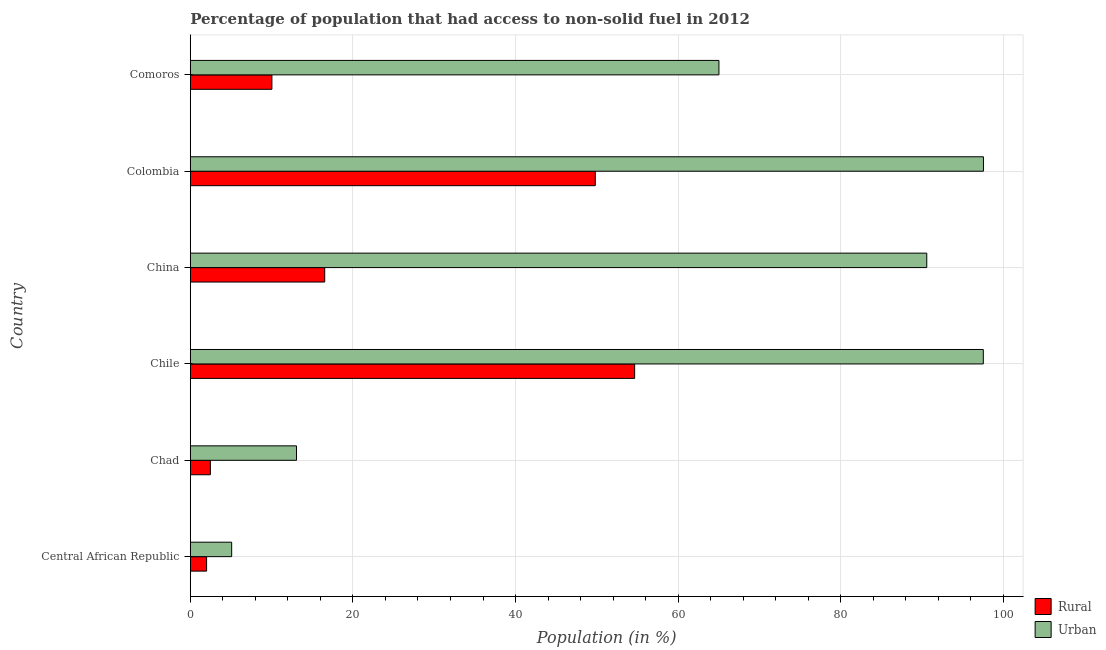Are the number of bars on each tick of the Y-axis equal?
Your answer should be very brief. Yes. What is the label of the 1st group of bars from the top?
Your answer should be compact. Comoros. In how many cases, is the number of bars for a given country not equal to the number of legend labels?
Your answer should be compact. 0. What is the rural population in Colombia?
Offer a terse response. 49.81. Across all countries, what is the maximum urban population?
Your answer should be compact. 97.55. Across all countries, what is the minimum rural population?
Your answer should be very brief. 2. In which country was the urban population minimum?
Your answer should be very brief. Central African Republic. What is the total rural population in the graph?
Keep it short and to the point. 135.5. What is the difference between the urban population in Chad and that in China?
Offer a very short reply. -77.51. What is the difference between the rural population in Central African Republic and the urban population in Chad?
Your response must be concise. -11.06. What is the average rural population per country?
Give a very brief answer. 22.58. What is the difference between the rural population and urban population in Comoros?
Your response must be concise. -54.98. What is the ratio of the urban population in Chad to that in Colombia?
Give a very brief answer. 0.13. Is the difference between the urban population in Chad and Chile greater than the difference between the rural population in Chad and Chile?
Provide a succinct answer. No. What is the difference between the highest and the second highest rural population?
Give a very brief answer. 4.84. What is the difference between the highest and the lowest urban population?
Give a very brief answer. 92.46. What does the 1st bar from the top in Chad represents?
Make the answer very short. Urban. What does the 2nd bar from the bottom in Central African Republic represents?
Ensure brevity in your answer.  Urban. How many bars are there?
Provide a short and direct response. 12. Where does the legend appear in the graph?
Offer a very short reply. Bottom right. How many legend labels are there?
Give a very brief answer. 2. How are the legend labels stacked?
Provide a short and direct response. Vertical. What is the title of the graph?
Provide a succinct answer. Percentage of population that had access to non-solid fuel in 2012. Does "Infant" appear as one of the legend labels in the graph?
Keep it short and to the point. No. What is the label or title of the X-axis?
Make the answer very short. Population (in %). What is the Population (in %) in Rural in Central African Republic?
Your answer should be very brief. 2. What is the Population (in %) of Urban in Central African Republic?
Your answer should be very brief. 5.09. What is the Population (in %) in Rural in Chad?
Give a very brief answer. 2.47. What is the Population (in %) in Urban in Chad?
Provide a short and direct response. 13.06. What is the Population (in %) in Rural in Chile?
Keep it short and to the point. 54.65. What is the Population (in %) in Urban in Chile?
Offer a very short reply. 97.53. What is the Population (in %) of Rural in China?
Keep it short and to the point. 16.53. What is the Population (in %) in Urban in China?
Make the answer very short. 90.57. What is the Population (in %) in Rural in Colombia?
Ensure brevity in your answer.  49.81. What is the Population (in %) in Urban in Colombia?
Your answer should be very brief. 97.55. What is the Population (in %) of Rural in Comoros?
Ensure brevity in your answer.  10.04. What is the Population (in %) of Urban in Comoros?
Provide a short and direct response. 65.02. Across all countries, what is the maximum Population (in %) of Rural?
Keep it short and to the point. 54.65. Across all countries, what is the maximum Population (in %) in Urban?
Keep it short and to the point. 97.55. Across all countries, what is the minimum Population (in %) in Rural?
Provide a succinct answer. 2. Across all countries, what is the minimum Population (in %) of Urban?
Offer a terse response. 5.09. What is the total Population (in %) in Rural in the graph?
Give a very brief answer. 135.5. What is the total Population (in %) in Urban in the graph?
Ensure brevity in your answer.  368.82. What is the difference between the Population (in %) in Rural in Central African Republic and that in Chad?
Ensure brevity in your answer.  -0.47. What is the difference between the Population (in %) in Urban in Central African Republic and that in Chad?
Offer a very short reply. -7.97. What is the difference between the Population (in %) in Rural in Central African Republic and that in Chile?
Provide a short and direct response. -52.64. What is the difference between the Population (in %) of Urban in Central African Republic and that in Chile?
Give a very brief answer. -92.44. What is the difference between the Population (in %) in Rural in Central African Republic and that in China?
Offer a very short reply. -14.53. What is the difference between the Population (in %) in Urban in Central African Republic and that in China?
Offer a very short reply. -85.48. What is the difference between the Population (in %) in Rural in Central African Republic and that in Colombia?
Provide a short and direct response. -47.8. What is the difference between the Population (in %) of Urban in Central African Republic and that in Colombia?
Your response must be concise. -92.46. What is the difference between the Population (in %) of Rural in Central African Republic and that in Comoros?
Make the answer very short. -8.03. What is the difference between the Population (in %) of Urban in Central African Republic and that in Comoros?
Offer a very short reply. -59.93. What is the difference between the Population (in %) in Rural in Chad and that in Chile?
Your response must be concise. -52.18. What is the difference between the Population (in %) in Urban in Chad and that in Chile?
Provide a short and direct response. -84.47. What is the difference between the Population (in %) in Rural in Chad and that in China?
Keep it short and to the point. -14.06. What is the difference between the Population (in %) in Urban in Chad and that in China?
Make the answer very short. -77.51. What is the difference between the Population (in %) in Rural in Chad and that in Colombia?
Provide a short and direct response. -47.34. What is the difference between the Population (in %) of Urban in Chad and that in Colombia?
Your answer should be compact. -84.49. What is the difference between the Population (in %) in Rural in Chad and that in Comoros?
Your answer should be compact. -7.57. What is the difference between the Population (in %) of Urban in Chad and that in Comoros?
Your response must be concise. -51.95. What is the difference between the Population (in %) of Rural in Chile and that in China?
Ensure brevity in your answer.  38.12. What is the difference between the Population (in %) in Urban in Chile and that in China?
Offer a terse response. 6.95. What is the difference between the Population (in %) of Rural in Chile and that in Colombia?
Your answer should be compact. 4.84. What is the difference between the Population (in %) in Urban in Chile and that in Colombia?
Ensure brevity in your answer.  -0.02. What is the difference between the Population (in %) of Rural in Chile and that in Comoros?
Your answer should be very brief. 44.61. What is the difference between the Population (in %) in Urban in Chile and that in Comoros?
Your answer should be compact. 32.51. What is the difference between the Population (in %) in Rural in China and that in Colombia?
Your answer should be compact. -33.27. What is the difference between the Population (in %) of Urban in China and that in Colombia?
Your response must be concise. -6.97. What is the difference between the Population (in %) in Rural in China and that in Comoros?
Your answer should be very brief. 6.49. What is the difference between the Population (in %) of Urban in China and that in Comoros?
Your answer should be very brief. 25.56. What is the difference between the Population (in %) in Rural in Colombia and that in Comoros?
Make the answer very short. 39.77. What is the difference between the Population (in %) of Urban in Colombia and that in Comoros?
Your answer should be very brief. 32.53. What is the difference between the Population (in %) in Rural in Central African Republic and the Population (in %) in Urban in Chad?
Your response must be concise. -11.06. What is the difference between the Population (in %) of Rural in Central African Republic and the Population (in %) of Urban in Chile?
Provide a succinct answer. -95.52. What is the difference between the Population (in %) of Rural in Central African Republic and the Population (in %) of Urban in China?
Your answer should be very brief. -88.57. What is the difference between the Population (in %) of Rural in Central African Republic and the Population (in %) of Urban in Colombia?
Provide a succinct answer. -95.54. What is the difference between the Population (in %) of Rural in Central African Republic and the Population (in %) of Urban in Comoros?
Your response must be concise. -63.01. What is the difference between the Population (in %) of Rural in Chad and the Population (in %) of Urban in Chile?
Provide a succinct answer. -95.06. What is the difference between the Population (in %) in Rural in Chad and the Population (in %) in Urban in China?
Your answer should be compact. -88.11. What is the difference between the Population (in %) of Rural in Chad and the Population (in %) of Urban in Colombia?
Ensure brevity in your answer.  -95.08. What is the difference between the Population (in %) in Rural in Chad and the Population (in %) in Urban in Comoros?
Ensure brevity in your answer.  -62.55. What is the difference between the Population (in %) in Rural in Chile and the Population (in %) in Urban in China?
Your answer should be compact. -35.93. What is the difference between the Population (in %) of Rural in Chile and the Population (in %) of Urban in Colombia?
Keep it short and to the point. -42.9. What is the difference between the Population (in %) in Rural in Chile and the Population (in %) in Urban in Comoros?
Provide a short and direct response. -10.37. What is the difference between the Population (in %) of Rural in China and the Population (in %) of Urban in Colombia?
Your answer should be very brief. -81.02. What is the difference between the Population (in %) in Rural in China and the Population (in %) in Urban in Comoros?
Make the answer very short. -48.48. What is the difference between the Population (in %) of Rural in Colombia and the Population (in %) of Urban in Comoros?
Your response must be concise. -15.21. What is the average Population (in %) in Rural per country?
Keep it short and to the point. 22.58. What is the average Population (in %) of Urban per country?
Your response must be concise. 61.47. What is the difference between the Population (in %) in Rural and Population (in %) in Urban in Central African Republic?
Ensure brevity in your answer.  -3.09. What is the difference between the Population (in %) of Rural and Population (in %) of Urban in Chad?
Your answer should be very brief. -10.59. What is the difference between the Population (in %) of Rural and Population (in %) of Urban in Chile?
Your response must be concise. -42.88. What is the difference between the Population (in %) of Rural and Population (in %) of Urban in China?
Provide a succinct answer. -74.04. What is the difference between the Population (in %) in Rural and Population (in %) in Urban in Colombia?
Offer a very short reply. -47.74. What is the difference between the Population (in %) of Rural and Population (in %) of Urban in Comoros?
Ensure brevity in your answer.  -54.98. What is the ratio of the Population (in %) in Rural in Central African Republic to that in Chad?
Keep it short and to the point. 0.81. What is the ratio of the Population (in %) of Urban in Central African Republic to that in Chad?
Give a very brief answer. 0.39. What is the ratio of the Population (in %) in Rural in Central African Republic to that in Chile?
Give a very brief answer. 0.04. What is the ratio of the Population (in %) in Urban in Central African Republic to that in Chile?
Your answer should be compact. 0.05. What is the ratio of the Population (in %) of Rural in Central African Republic to that in China?
Your response must be concise. 0.12. What is the ratio of the Population (in %) of Urban in Central African Republic to that in China?
Offer a very short reply. 0.06. What is the ratio of the Population (in %) of Rural in Central African Republic to that in Colombia?
Offer a terse response. 0.04. What is the ratio of the Population (in %) of Urban in Central African Republic to that in Colombia?
Your response must be concise. 0.05. What is the ratio of the Population (in %) of Rural in Central African Republic to that in Comoros?
Provide a succinct answer. 0.2. What is the ratio of the Population (in %) of Urban in Central African Republic to that in Comoros?
Offer a very short reply. 0.08. What is the ratio of the Population (in %) of Rural in Chad to that in Chile?
Your answer should be compact. 0.05. What is the ratio of the Population (in %) in Urban in Chad to that in Chile?
Offer a terse response. 0.13. What is the ratio of the Population (in %) in Rural in Chad to that in China?
Give a very brief answer. 0.15. What is the ratio of the Population (in %) of Urban in Chad to that in China?
Your answer should be very brief. 0.14. What is the ratio of the Population (in %) in Rural in Chad to that in Colombia?
Offer a very short reply. 0.05. What is the ratio of the Population (in %) in Urban in Chad to that in Colombia?
Ensure brevity in your answer.  0.13. What is the ratio of the Population (in %) of Rural in Chad to that in Comoros?
Ensure brevity in your answer.  0.25. What is the ratio of the Population (in %) in Urban in Chad to that in Comoros?
Your response must be concise. 0.2. What is the ratio of the Population (in %) in Rural in Chile to that in China?
Offer a very short reply. 3.31. What is the ratio of the Population (in %) of Urban in Chile to that in China?
Make the answer very short. 1.08. What is the ratio of the Population (in %) of Rural in Chile to that in Colombia?
Ensure brevity in your answer.  1.1. What is the ratio of the Population (in %) in Rural in Chile to that in Comoros?
Your answer should be very brief. 5.44. What is the ratio of the Population (in %) of Urban in Chile to that in Comoros?
Give a very brief answer. 1.5. What is the ratio of the Population (in %) in Rural in China to that in Colombia?
Give a very brief answer. 0.33. What is the ratio of the Population (in %) in Urban in China to that in Colombia?
Give a very brief answer. 0.93. What is the ratio of the Population (in %) of Rural in China to that in Comoros?
Your response must be concise. 1.65. What is the ratio of the Population (in %) in Urban in China to that in Comoros?
Ensure brevity in your answer.  1.39. What is the ratio of the Population (in %) in Rural in Colombia to that in Comoros?
Keep it short and to the point. 4.96. What is the ratio of the Population (in %) in Urban in Colombia to that in Comoros?
Provide a succinct answer. 1.5. What is the difference between the highest and the second highest Population (in %) in Rural?
Keep it short and to the point. 4.84. What is the difference between the highest and the second highest Population (in %) in Urban?
Offer a very short reply. 0.02. What is the difference between the highest and the lowest Population (in %) in Rural?
Keep it short and to the point. 52.64. What is the difference between the highest and the lowest Population (in %) in Urban?
Make the answer very short. 92.46. 